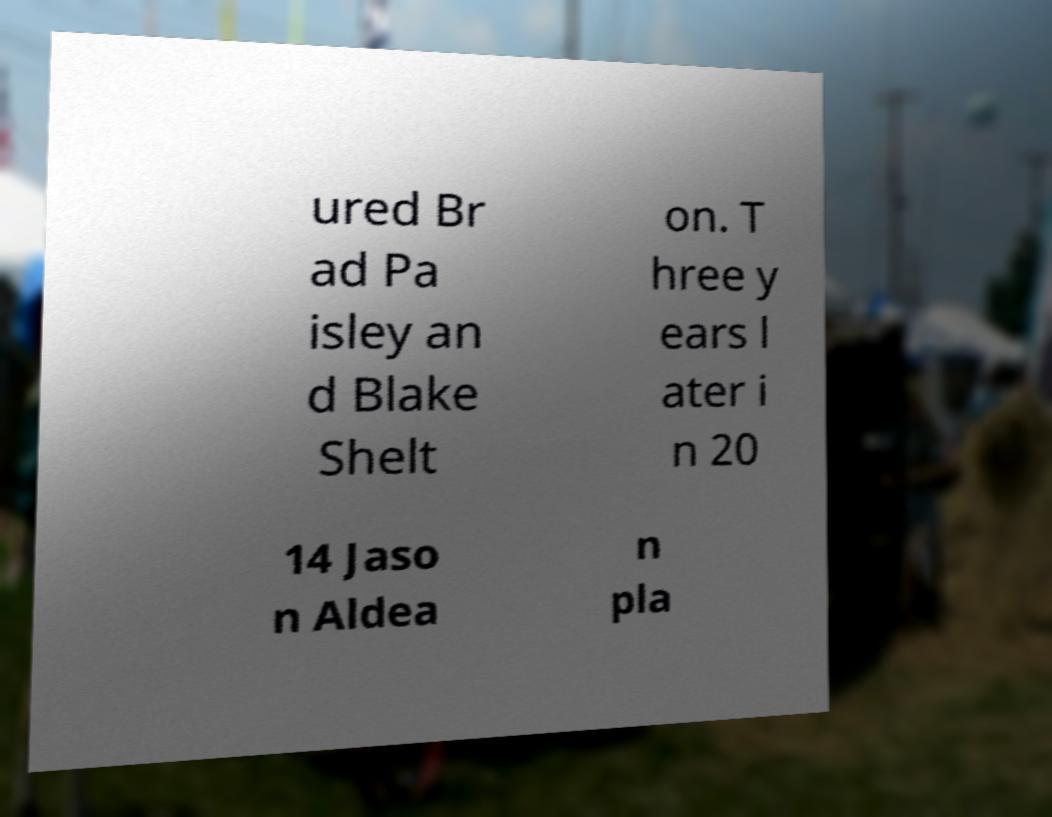Could you assist in decoding the text presented in this image and type it out clearly? ured Br ad Pa isley an d Blake Shelt on. T hree y ears l ater i n 20 14 Jaso n Aldea n pla 